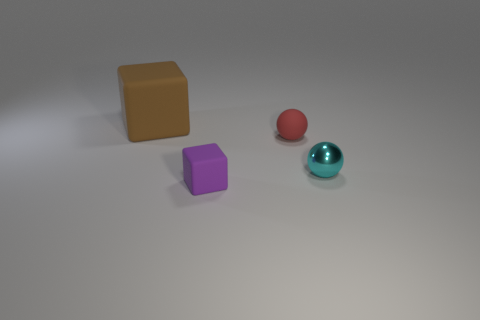Add 3 large green matte cubes. How many objects exist? 7 Subtract 1 red balls. How many objects are left? 3 Subtract all tiny cyan metal spheres. Subtract all tiny gray metal cubes. How many objects are left? 3 Add 1 purple rubber objects. How many purple rubber objects are left? 2 Add 4 tiny metal balls. How many tiny metal balls exist? 5 